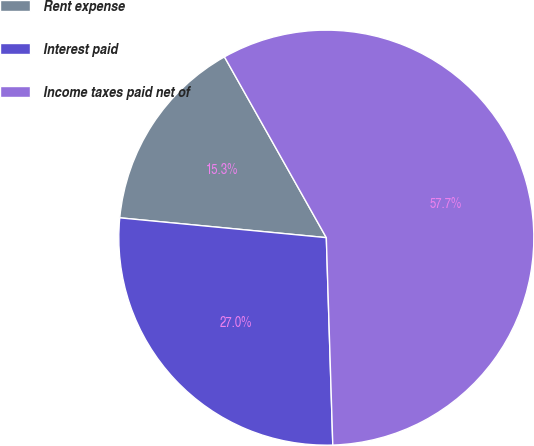<chart> <loc_0><loc_0><loc_500><loc_500><pie_chart><fcel>Rent expense<fcel>Interest paid<fcel>Income taxes paid net of<nl><fcel>15.31%<fcel>27.02%<fcel>57.67%<nl></chart> 